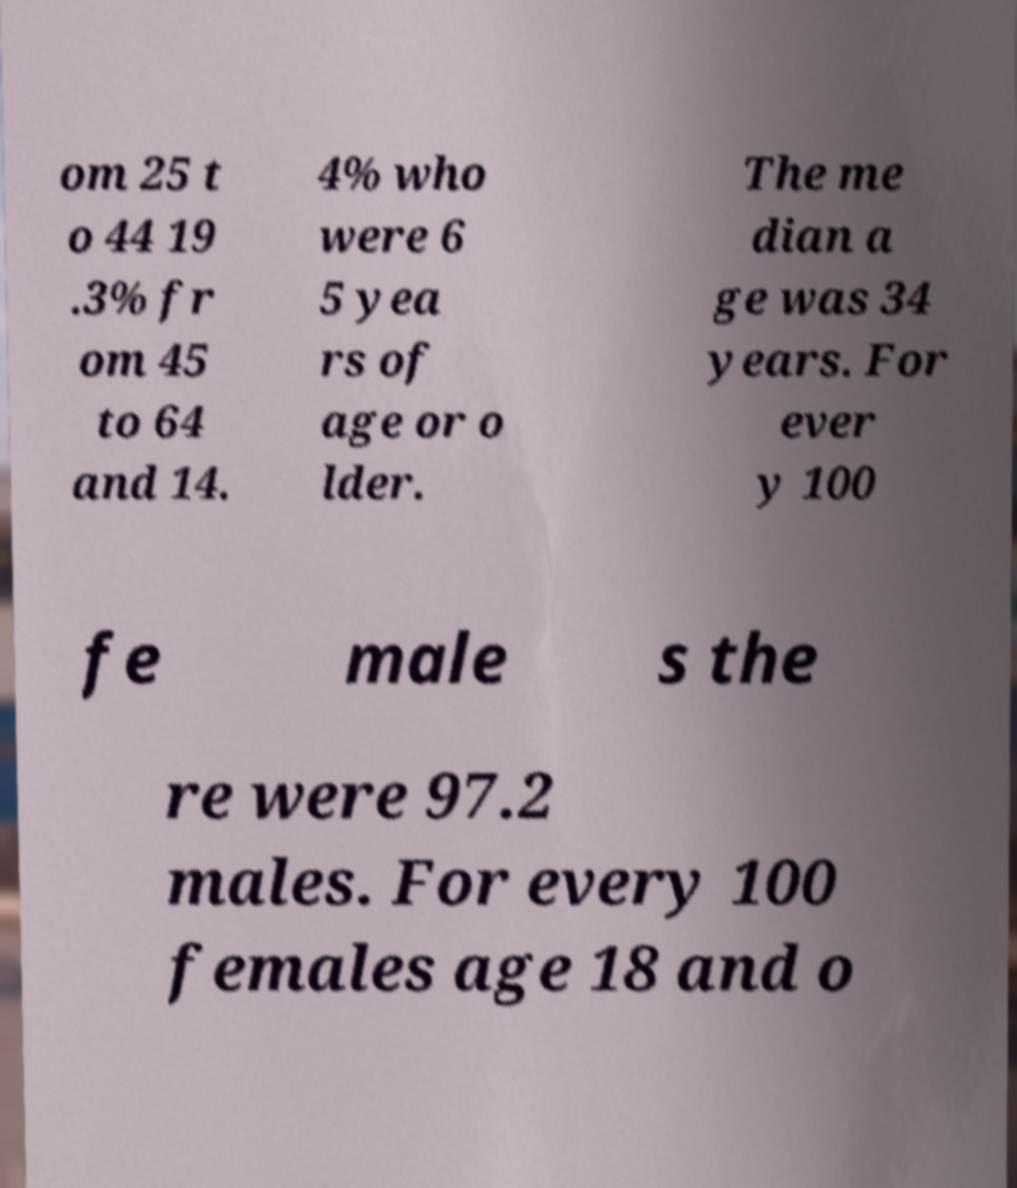Can you read and provide the text displayed in the image?This photo seems to have some interesting text. Can you extract and type it out for me? om 25 t o 44 19 .3% fr om 45 to 64 and 14. 4% who were 6 5 yea rs of age or o lder. The me dian a ge was 34 years. For ever y 100 fe male s the re were 97.2 males. For every 100 females age 18 and o 